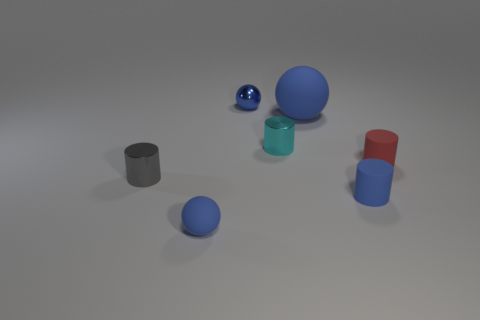The tiny shiny object that is the same color as the large ball is what shape?
Your answer should be very brief. Sphere. What number of big things are the same color as the metal sphere?
Your answer should be compact. 1. There is another small sphere that is the same color as the tiny matte ball; what is it made of?
Ensure brevity in your answer.  Metal. There is a small sphere that is left of the blue metallic object; does it have the same color as the tiny metal sphere?
Provide a short and direct response. Yes. There is a blue metal object that is the same size as the gray object; what shape is it?
Your response must be concise. Sphere. How many other objects are there of the same color as the large rubber sphere?
Your answer should be compact. 3. What number of other objects are the same material as the tiny red thing?
Offer a very short reply. 3. There is a gray object; is its size the same as the blue object that is on the right side of the large blue ball?
Make the answer very short. Yes. What color is the big matte object?
Offer a very short reply. Blue. What shape is the small blue shiny thing behind the tiny thing right of the blue rubber thing to the right of the large ball?
Offer a terse response. Sphere. 